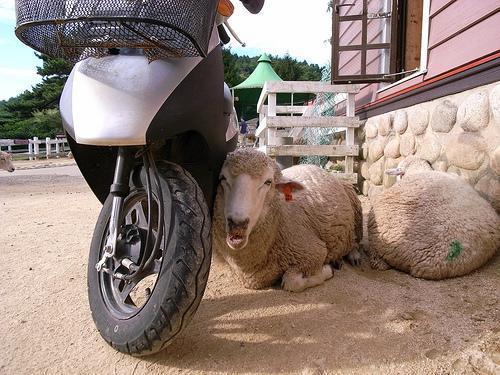How many sheep are there?
Give a very brief answer. 2. How many animals are pictured here?
Give a very brief answer. 2. How many vehicles are pictured?
Give a very brief answer. 1. 